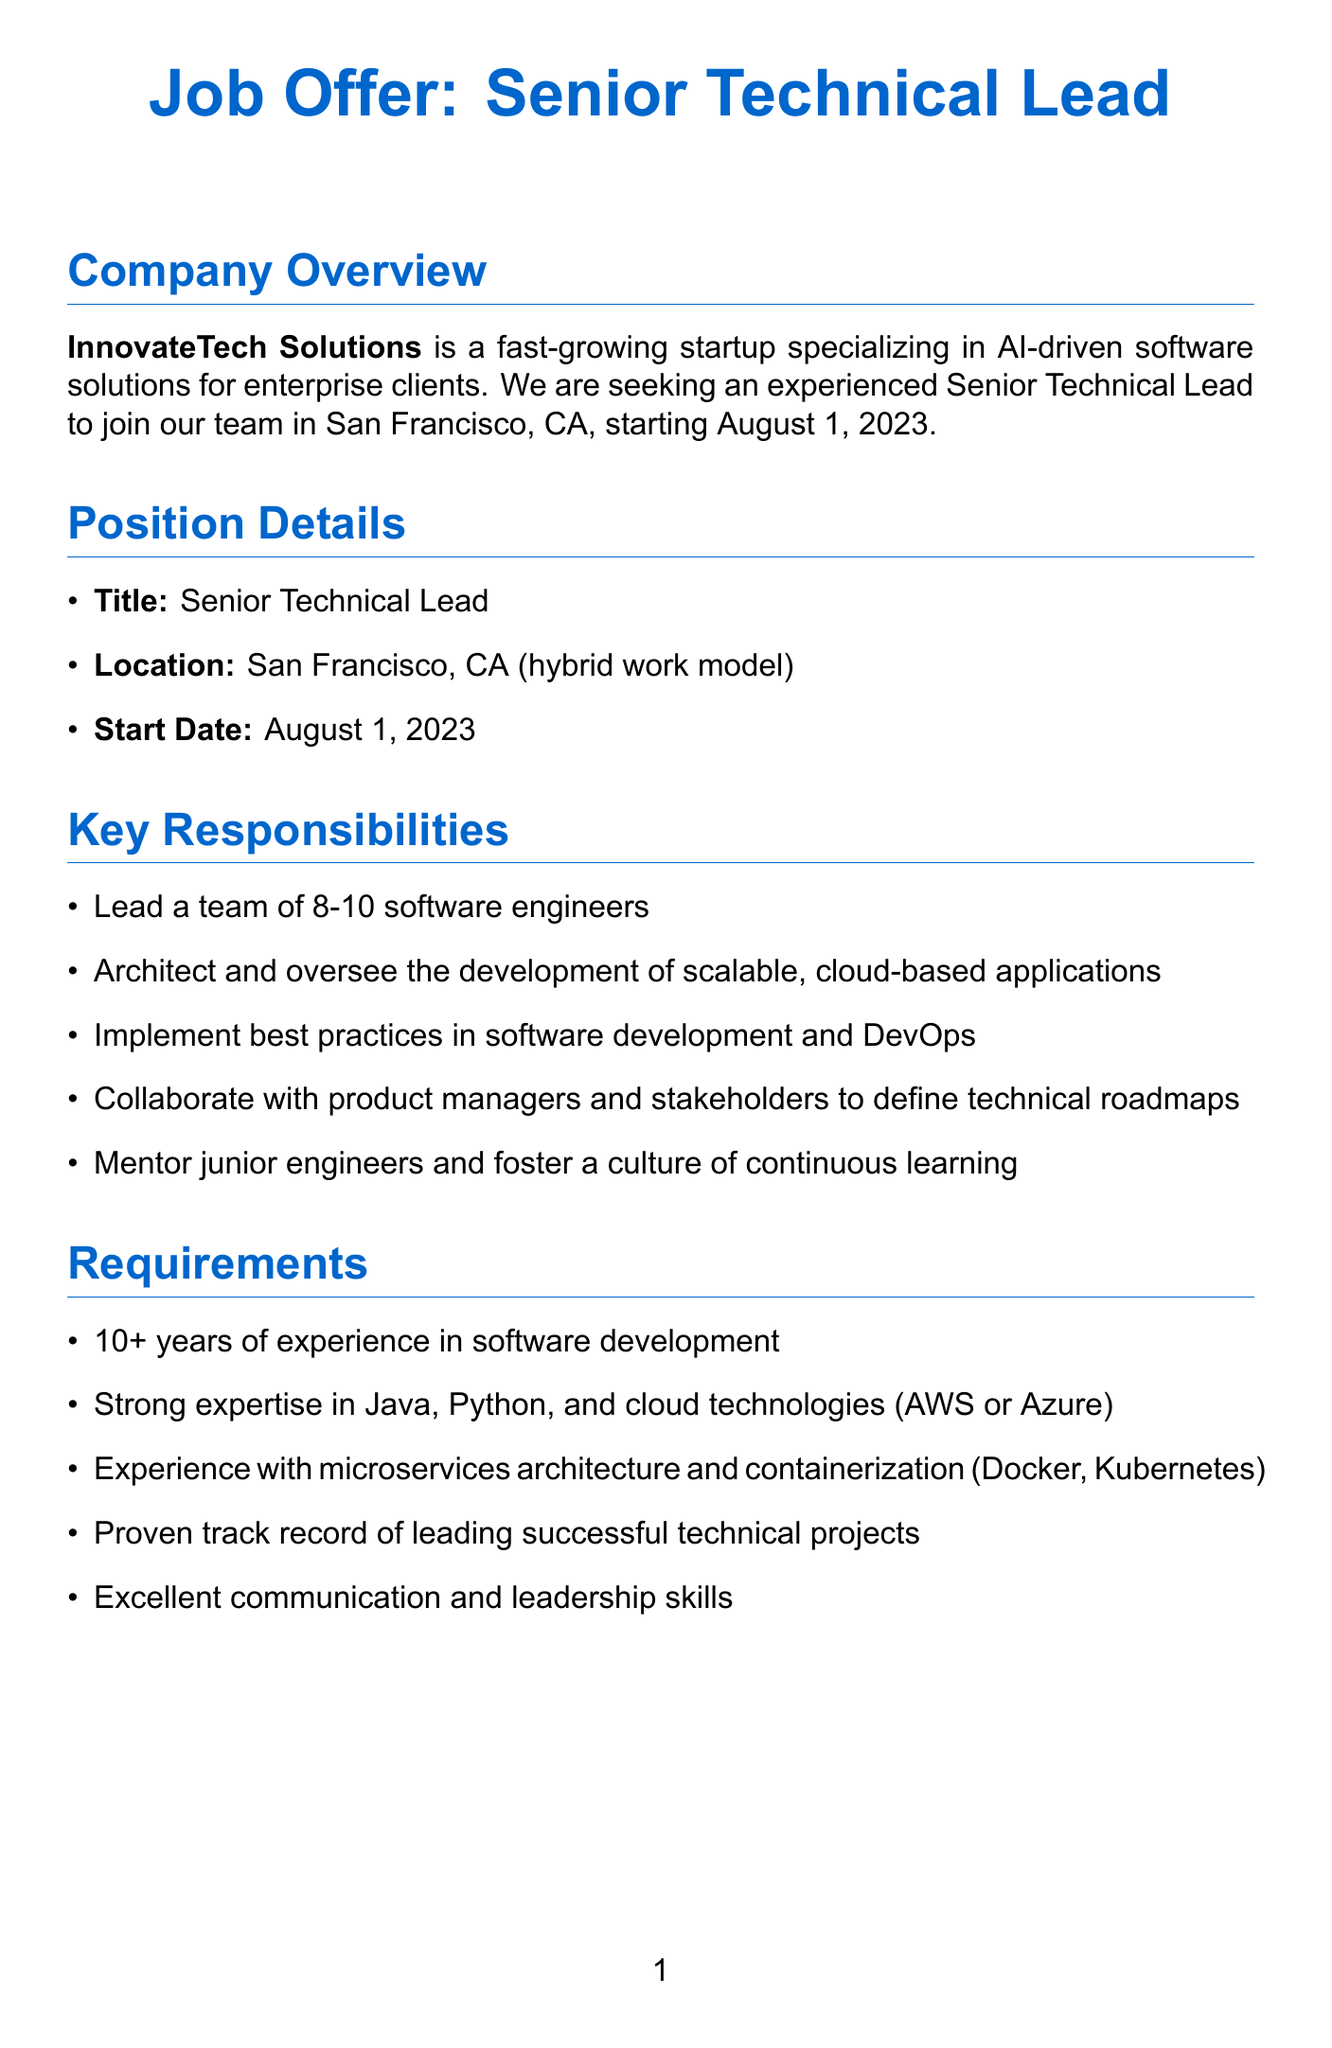What is the name of the company? The company name is mentioned at the beginning of the document.
Answer: InnovateTech Solutions What is the location for the position? The location is specified under Position Details, indicating where the job will be based.
Answer: San Francisco, CA Who is the hiring manager? The hiring manager's name and title are listed towards the end of the document.
Answer: Sarah Chen What is the base salary range? The compensation section provides a specific salary figure that outlines the base pay.
Answer: $180,000 - $220,000 per year How many software engineers will the Senior Technical Lead lead? The responsibilities section details the size of the team under the Senior Technical Lead's supervision.
Answer: 8-10 What opportunity is mentioned for career advancement? The Growth Opportunities section lists potential roles for career growth.
Answer: VP of Engineering or CTO roles What type of work model is offered? The Position Details section specifies the work model that the employees will follow.
Answer: Hybrid work model How many key projects are listed? The Key Projects section states the number of projects that the company is focusing on.
Answer: 3 What is one of the benefits provided? The Benefits section lists advantages provided to employees.
Answer: Comprehensive health, dental, and vision insurance 